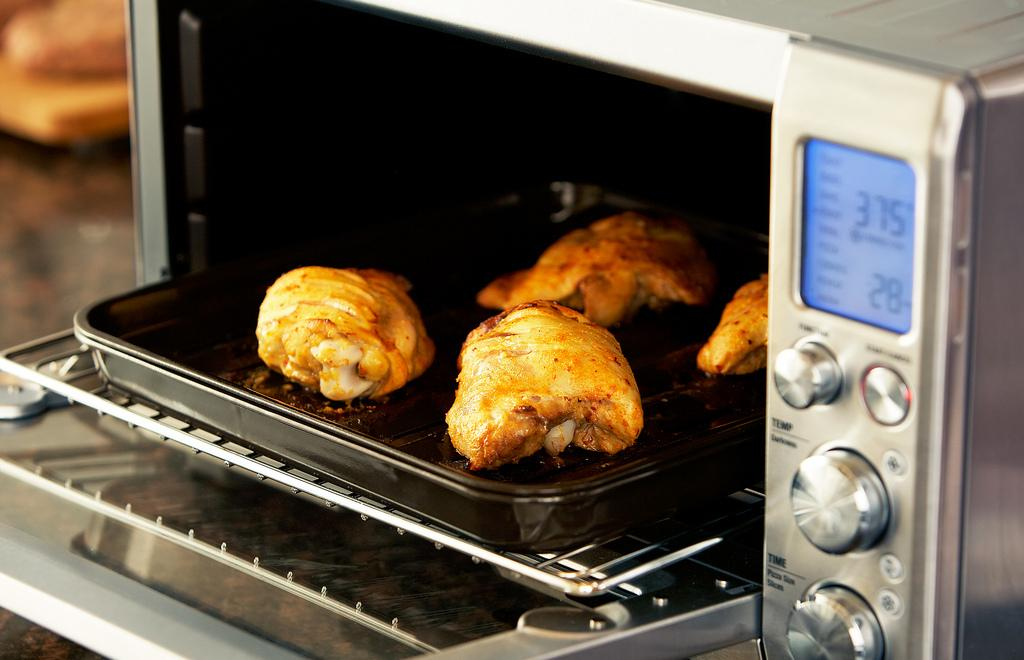<image>
Provide a brief description of the given image. Food has finished cooking in an oven that was set to 375 degrees. 